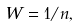Convert formula to latex. <formula><loc_0><loc_0><loc_500><loc_500>W = 1 / n ,</formula> 